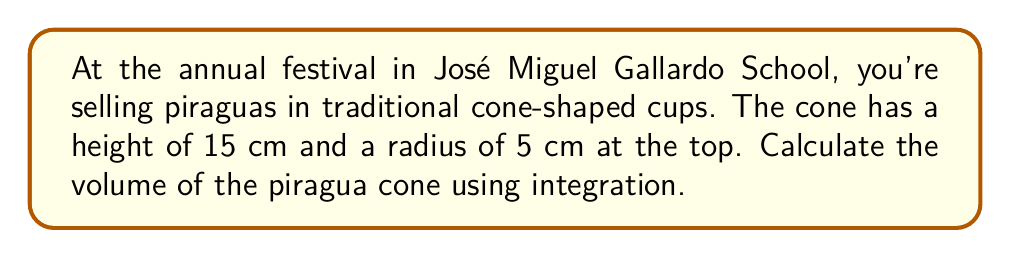Could you help me with this problem? Let's approach this step-by-step:

1) The volume of a solid of revolution can be calculated using the formula:

   $$V = \int_0^h \pi r(x)^2 dx$$

   where $h$ is the height of the cone and $r(x)$ is the radius at height $x$.

2) For a cone, the radius at any height $x$ is given by the equation:

   $$r(x) = \frac{R}{h}(h-x)$$

   where $R$ is the radius at the base and $h$ is the height.

3) In our case, $R = 5$ cm and $h = 15$ cm. Substituting these values:

   $$r(x) = \frac{5}{15}(15-x) = \frac{1}{3}(15-x)$$

4) Now, let's set up our integral:

   $$V = \int_0^{15} \pi (\frac{1}{3}(15-x))^2 dx$$

5) Simplify the integrand:

   $$V = \pi \int_0^{15} \frac{1}{9}(225-30x+x^2) dx$$

6) Integrate:

   $$V = \pi [\frac{1}{9}(225x-15x^2+\frac{1}{3}x^3)]_0^{15}$$

7) Evaluate the integral:

   $$V = \pi [\frac{1}{9}(225(15)-15(15^2)+\frac{1}{3}(15^3)) - 0]$$

8) Simplify:

   $$V = \pi [\frac{1}{9}(3375-3375+1125)] = \pi \cdot \frac{1125}{9} = 125\pi$$

9) Therefore, the volume is $125\pi$ cubic centimeters.
Answer: $125\pi$ cm³ 